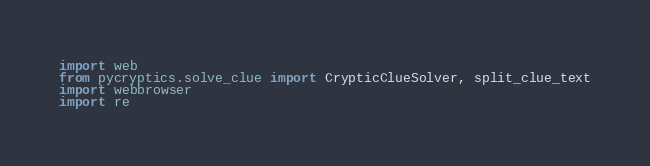Convert code to text. <code><loc_0><loc_0><loc_500><loc_500><_Python_>import web
from pycryptics.solve_clue import CrypticClueSolver, split_clue_text
import webbrowser
import re</code> 